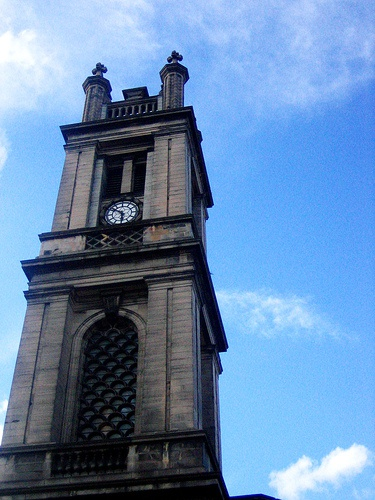Describe the objects in this image and their specific colors. I can see a clock in lavender, navy, lightgray, darkgray, and gray tones in this image. 